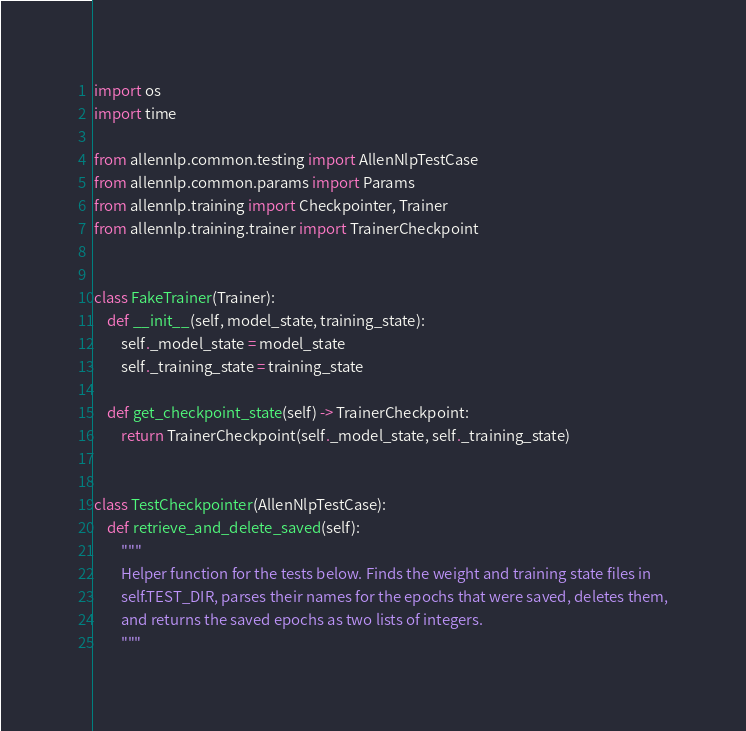Convert code to text. <code><loc_0><loc_0><loc_500><loc_500><_Python_>import os
import time

from allennlp.common.testing import AllenNlpTestCase
from allennlp.common.params import Params
from allennlp.training import Checkpointer, Trainer
from allennlp.training.trainer import TrainerCheckpoint


class FakeTrainer(Trainer):
    def __init__(self, model_state, training_state):
        self._model_state = model_state
        self._training_state = training_state

    def get_checkpoint_state(self) -> TrainerCheckpoint:
        return TrainerCheckpoint(self._model_state, self._training_state)


class TestCheckpointer(AllenNlpTestCase):
    def retrieve_and_delete_saved(self):
        """
        Helper function for the tests below. Finds the weight and training state files in
        self.TEST_DIR, parses their names for the epochs that were saved, deletes them,
        and returns the saved epochs as two lists of integers.
        """</code> 